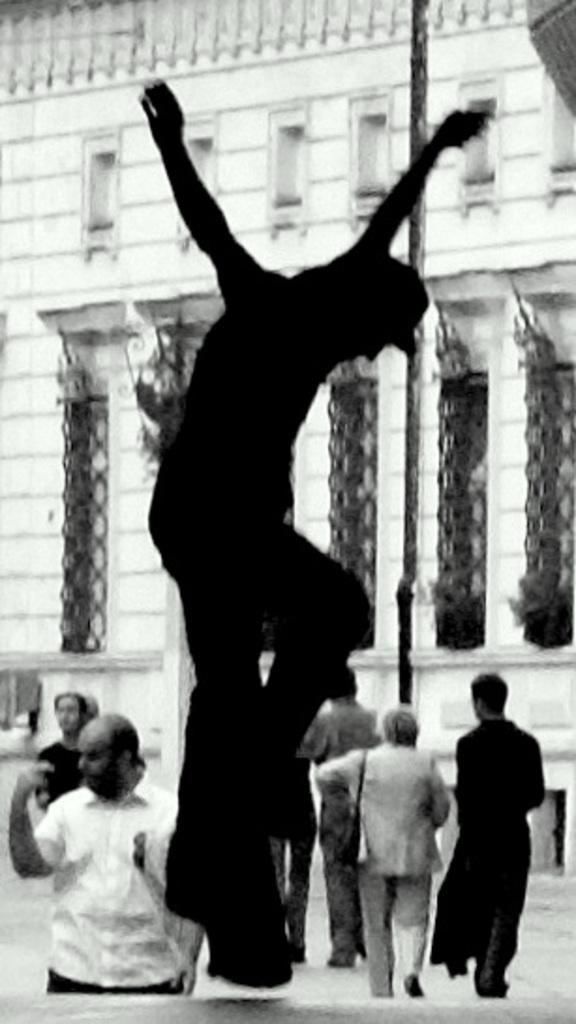What is the color scheme of the image? The image is black and white. What can be seen in the image besides the color scheme? There are people and a pole in the image. What type of structure is visible in the image? There is a building in the image. Where is the desk located in the image? There is no desk present in the image. What type of doll is sitting on the desk in the image? There is no doll or desk present in the image. 